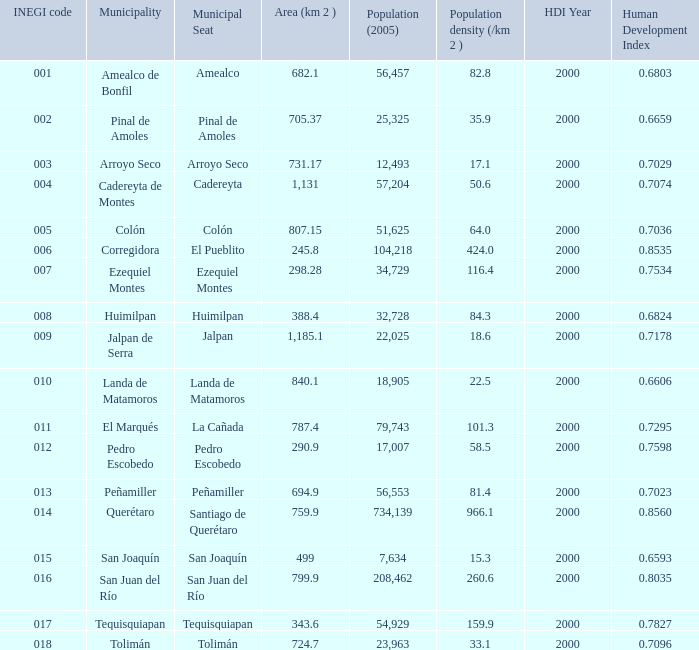WHat is the amount of Human Development Index (2000) that has a Population (2005) of 54,929, and an Area (km 2 ) larger than 343.6? 0.0. 